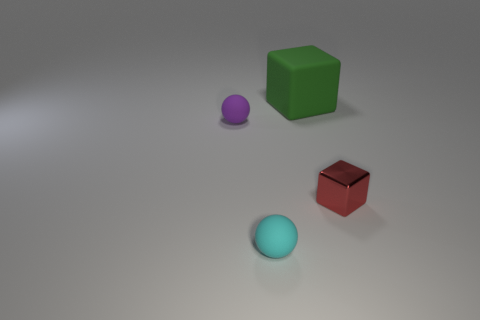Is there anything else that has the same material as the tiny red object?
Provide a short and direct response. No. Are there any other things that have the same size as the green block?
Your answer should be compact. No. How many other things are there of the same material as the tiny red cube?
Give a very brief answer. 0. Is the number of small things that are right of the purple rubber object greater than the number of tiny cyan things behind the green matte block?
Give a very brief answer. Yes. How many things are to the left of the shiny object?
Give a very brief answer. 3. Are the tiny cyan thing and the block that is behind the purple object made of the same material?
Provide a short and direct response. Yes. Does the tiny cyan ball have the same material as the tiny purple thing?
Offer a very short reply. Yes. Are there any spheres that are behind the small object that is in front of the tiny block?
Provide a succinct answer. Yes. What number of small objects are both behind the cyan ball and on the left side of the rubber block?
Make the answer very short. 1. What is the shape of the object that is in front of the tiny red metallic object?
Ensure brevity in your answer.  Sphere. 